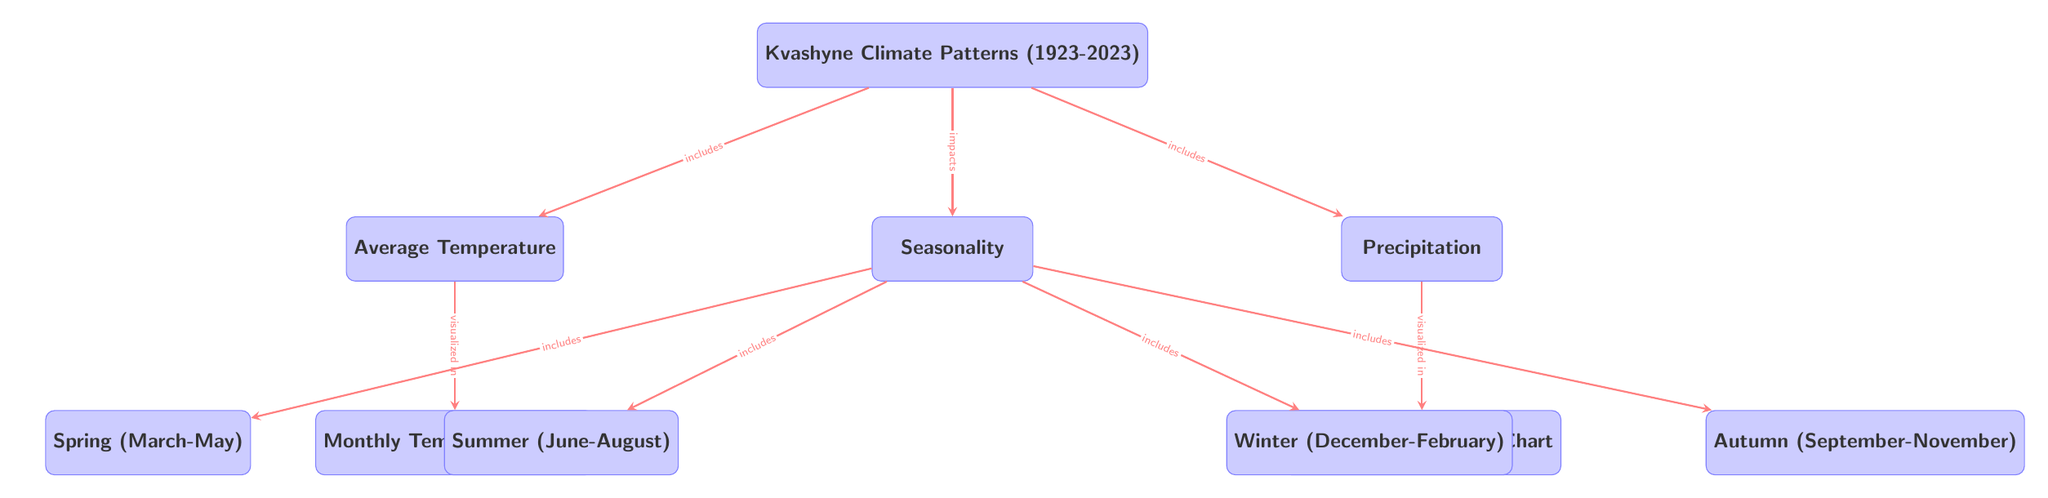What is the main topic of the diagram? The diagram clearly states at the top that the main topic is "Kvashyne Climate Patterns (1923-2023)". This indicates that the entire diagram focuses on climate patterns specific to Kvashyne over this timeframe.
Answer: Kvashyne Climate Patterns (1923-2023) How many seasonal categories are listed in the diagram? In the diagram, under the "Seasonality" node, there are four specified seasonal categories: Spring, Summer, Autumn, and Winter. By counting these nodes, we find a total of four categories.
Answer: 4 What does the "Average Temperature" node visualize? The "Average Temperature" node includes a sub-node labeled "Monthly Temperature Chart." This indicates that the average temperature data is visually represented in the form of a chart, specifically focusing on monthly variations.
Answer: Monthly Temperature Chart Which seasons include June to August? The diagram specifies that Summer (June-August) is one of the four season categories listed under the "Seasonality" node. By identifying the direct connection from the "Seasonality" node to the "Summer" node, we conclude that June to August falls within Summer.
Answer: Summer What does the "Precipitation" node visualize? Similar to the "Average Temperature" node, the "Precipitation" node is connected to a sub-node labeled "Monthly Precipitation Chart." This indicates that precipitation patterns are also represented visually in the form of a chart focusing on monthly data.
Answer: Monthly Precipitation Chart Which seasonal categories house the months December to February? The diagram indicates that the months December to February are part of the Winter category, as the Winter node directly branches from the "Seasonality" node. This specifies that those months are included in the Winter season.
Answer: Winter What does "Kvashyne Climate Patterns" impact according to the diagram? According to the diagram, the node labeled "Kvashyne Climate Patterns" directly connects to the "Seasonality" node with the label "impacts." This denotes that the climate patterns influence the seasonal variations described in the subsequent nodes.
Answer: Seasonality Is "Average Temperature" a direct child of "Climate Patterns"? Yes, in the diagram, the "Average Temperature" node is directly below the "Kvashyne Climate Patterns" node, indicating that it is a child node of this main topic and that average temperature is a significant component of climate patterns.
Answer: Yes 